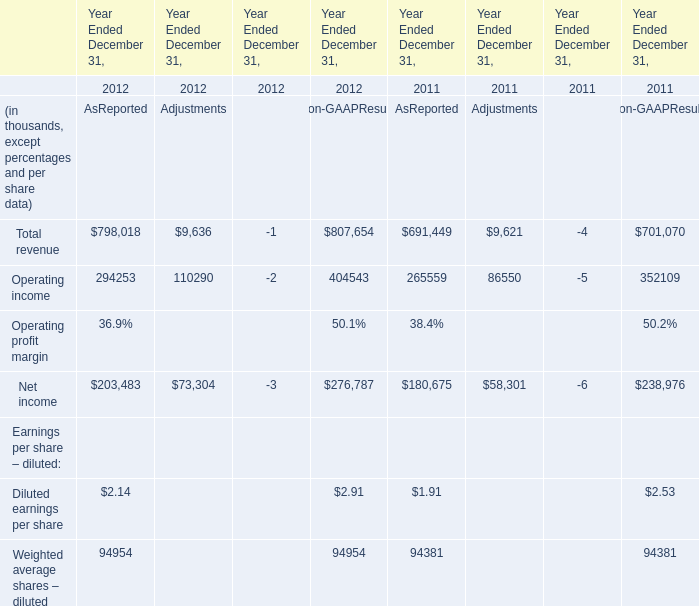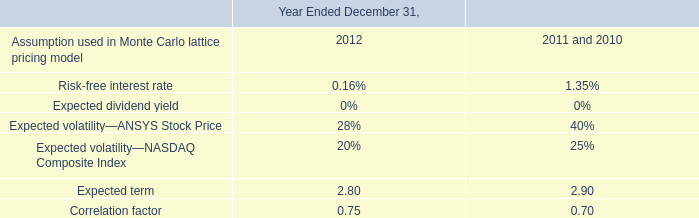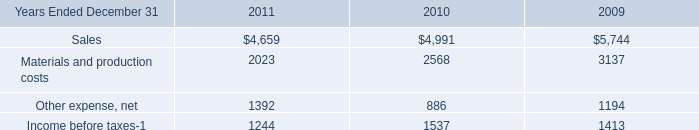What's the sum of Operating income of Year Ended December 31, 2012 AsReported, and Income before taxes of 2010 ? 
Computations: (294253.0 + 1537.0)
Answer: 295790.0. 